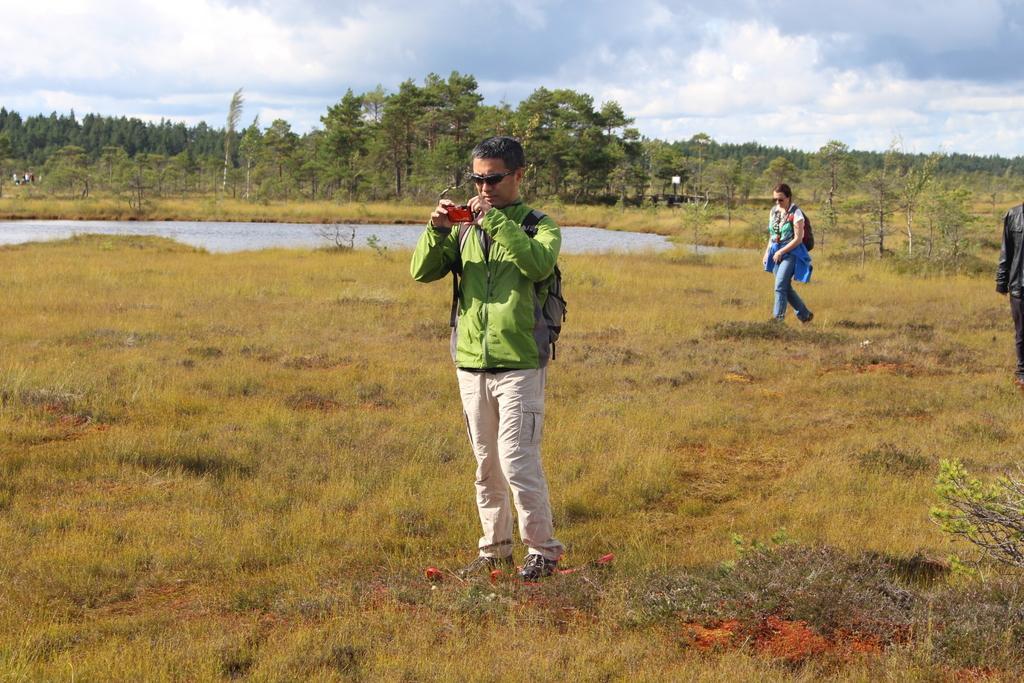In one or two sentences, can you explain what this image depicts? In this image I can see grass ground and on it I can see few people are standing. In the background I can see number of trees, water, clouds and the sky. In the front I can see a man is holding a red colour thing. 